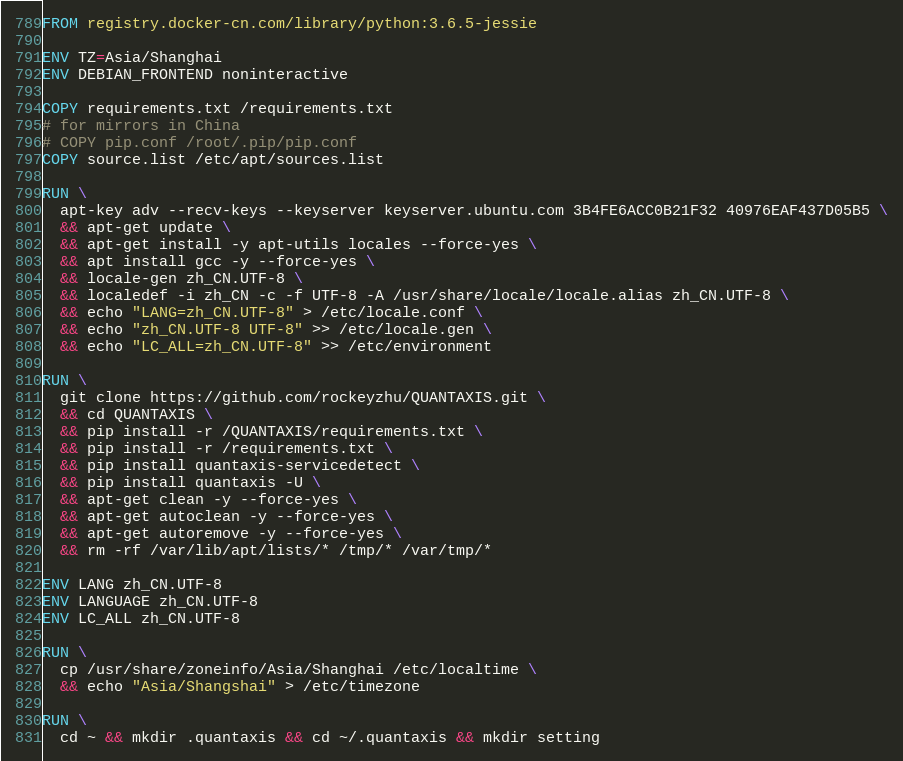<code> <loc_0><loc_0><loc_500><loc_500><_Dockerfile_>FROM registry.docker-cn.com/library/python:3.6.5-jessie

ENV TZ=Asia/Shanghai
ENV DEBIAN_FRONTEND noninteractive

COPY requirements.txt /requirements.txt
# for mirrors in China
# COPY pip.conf /root/.pip/pip.conf
COPY source.list /etc/apt/sources.list

RUN \
  apt-key adv --recv-keys --keyserver keyserver.ubuntu.com 3B4FE6ACC0B21F32 40976EAF437D05B5 \
  && apt-get update \
  && apt-get install -y apt-utils locales --force-yes \
  && apt install gcc -y --force-yes \
  && locale-gen zh_CN.UTF-8 \
  && localedef -i zh_CN -c -f UTF-8 -A /usr/share/locale/locale.alias zh_CN.UTF-8 \
  && echo "LANG=zh_CN.UTF-8" > /etc/locale.conf \
  && echo "zh_CN.UTF-8 UTF-8" >> /etc/locale.gen \
  && echo "LC_ALL=zh_CN.UTF-8" >> /etc/environment

RUN \
  git clone https://github.com/rockeyzhu/QUANTAXIS.git \
  && cd QUANTAXIS \
  && pip install -r /QUANTAXIS/requirements.txt \
  && pip install -r /requirements.txt \
  && pip install quantaxis-servicedetect \
  && pip install quantaxis -U \
  && apt-get clean -y --force-yes \
  && apt-get autoclean -y --force-yes \
  && apt-get autoremove -y --force-yes \
  && rm -rf /var/lib/apt/lists/* /tmp/* /var/tmp/*

ENV LANG zh_CN.UTF-8
ENV LANGUAGE zh_CN.UTF-8
ENV LC_ALL zh_CN.UTF-8

RUN \
  cp /usr/share/zoneinfo/Asia/Shanghai /etc/localtime \
  && echo "Asia/Shangshai" > /etc/timezone

RUN \
  cd ~ && mkdir .quantaxis && cd ~/.quantaxis && mkdir setting
</code> 